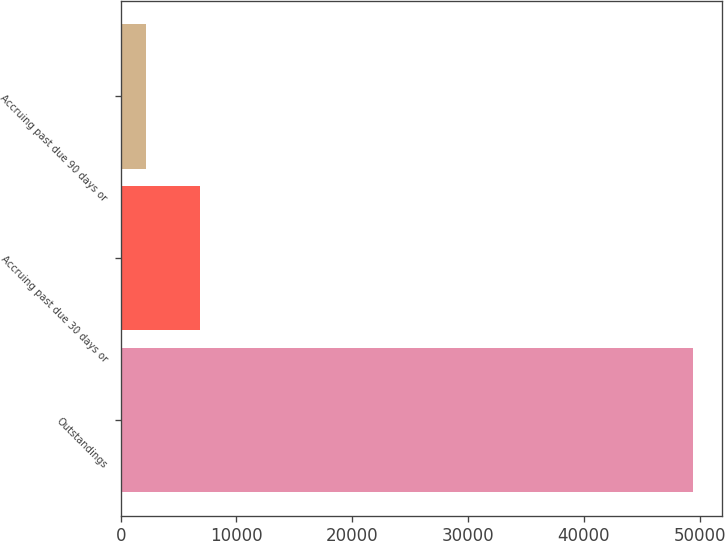<chart> <loc_0><loc_0><loc_500><loc_500><bar_chart><fcel>Outstandings<fcel>Accruing past due 30 days or<fcel>Accruing past due 90 days or<nl><fcel>49453<fcel>6887.5<fcel>2158<nl></chart> 